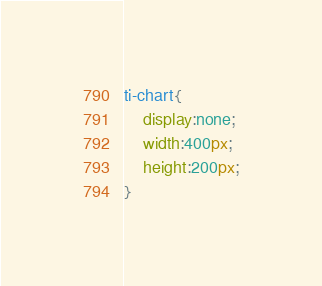<code> <loc_0><loc_0><loc_500><loc_500><_CSS_>ti-chart{
    display:none;
    width:400px;
    height:200px;
}</code> 